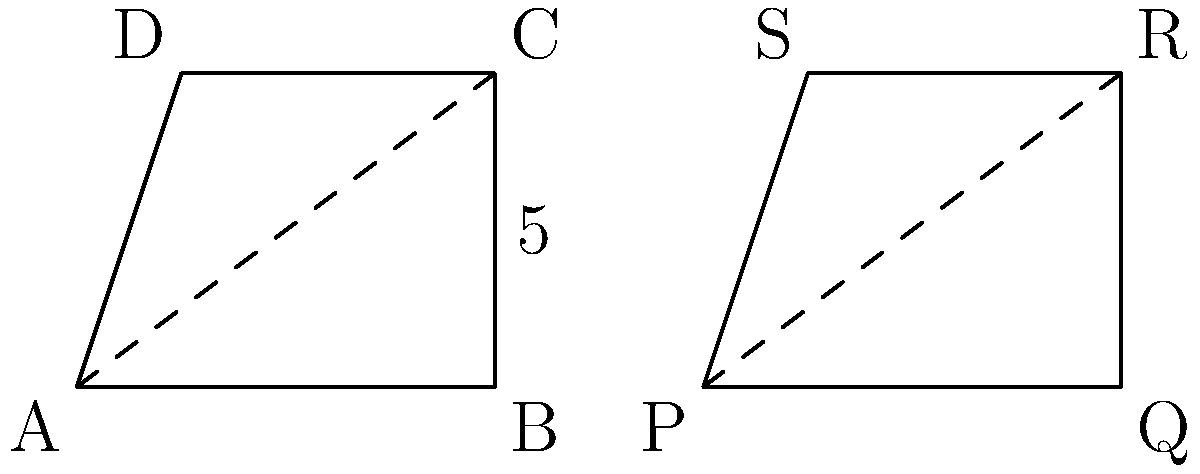Look at the two quadrilaterals ABCD and PQRS. Are they congruent? Explain your reasoning using the given information in the diagram. To determine if the quadrilaterals are congruent, we need to check if they have the same shape and size. Let's follow these steps:

1. Compare the side lengths:
   - AB = PQ = 4 units
   - BC = QR = 5 units
   - CD = RS = 3 units
   - DA = SP = 3 units
   All corresponding sides are equal.

2. Check the diagonals:
   - AC and PR are both shown as dashed lines, indicating they are diagonals.
   - The diagonals divide each quadrilateral into two equal triangles.

3. Examine the angles:
   - Since the side lengths are the same and the diagonals create equal triangles, the corresponding angles must also be equal.

4. Apply the definition of congruence:
   - Two shapes are congruent if they have the same shape and size.
   - We've confirmed that all sides, angles, and diagonals correspond.

Therefore, quadrilaterals ABCD and PQRS have the same shape and size, meeting the definition of congruence.
Answer: Yes, congruent. 